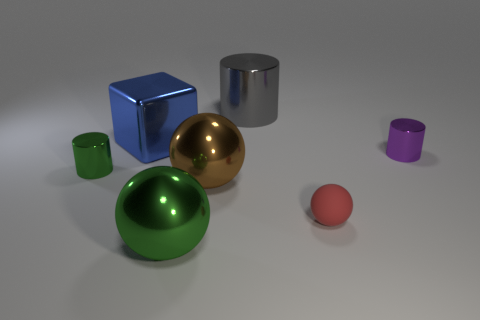Are there more spherical objects than cubic ones? Yes, there are more spherical objects in the image. We can see three spheres in total: a gold one, a green one, and a small red one. On the other hand, there is only one cubic object, which is blue. 